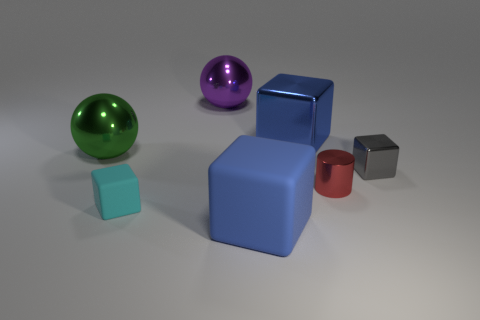There is a big blue thing that is the same material as the gray block; what is its shape?
Keep it short and to the point. Cube. Is there anything else that has the same color as the cylinder?
Give a very brief answer. No. What number of big metallic spheres are there?
Make the answer very short. 2. There is a metallic thing that is in front of the blue shiny cube and behind the tiny gray thing; what is its shape?
Make the answer very short. Sphere. There is a big blue thing behind the blue object that is in front of the cube left of the blue matte object; what is its shape?
Give a very brief answer. Cube. The object that is both right of the tiny matte object and in front of the tiny metallic cylinder is made of what material?
Give a very brief answer. Rubber. What number of purple balls are the same size as the green sphere?
Your answer should be compact. 1. What number of metallic things are either cyan objects or tiny yellow cubes?
Your response must be concise. 0. What is the gray object made of?
Make the answer very short. Metal. There is a large matte object; how many purple shiny things are to the left of it?
Your answer should be compact. 1. 